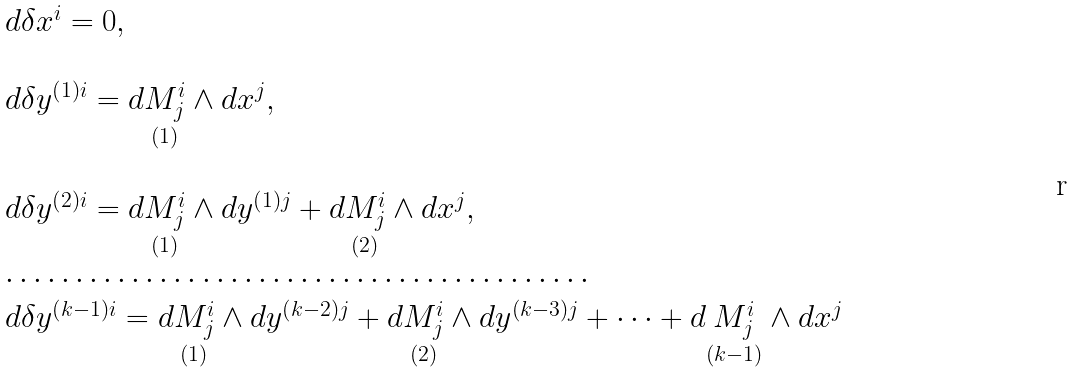<formula> <loc_0><loc_0><loc_500><loc_500>\begin{array} { l } d \delta x ^ { i } = 0 , \\ \\ d \delta y ^ { \left ( 1 \right ) i } = d \underset { ( 1 ) } { M _ { j } ^ { i } } \wedge d x ^ { j } , \\ \\ d \delta y ^ { \left ( 2 \right ) i } = d \underset { ( 1 ) } { M _ { j } ^ { i } } \wedge d y ^ { \left ( 1 \right ) j } + d \underset { ( 2 ) } { M _ { j } ^ { i } } \wedge d x ^ { j } , \\ \cdots \cdots \cdots \cdots \cdots \cdots \cdots \cdots \cdots \cdots \cdots \cdots \cdots \cdots \\ d \delta y ^ { \left ( k - 1 \right ) i } = d \underset { ( 1 ) } { M _ { j } ^ { i } } \wedge d y ^ { \left ( k - 2 \right ) j } + d \underset { ( 2 ) } { M _ { j } ^ { i } } \wedge d y ^ { \left ( k - 3 \right ) j } + \dots + d \underset { ( k - 1 ) } { M _ { j } ^ { i } } \wedge d x ^ { j } \end{array}</formula> 